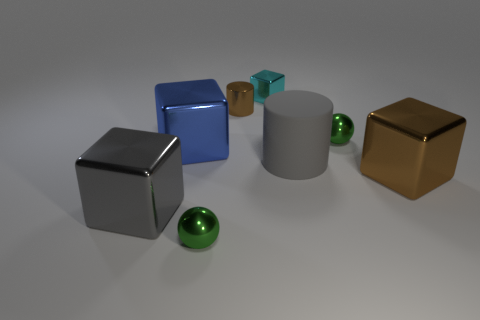Do the gray matte cylinder and the cyan object have the same size?
Make the answer very short. No. How many objects are large shiny cubes that are right of the big blue thing or metallic things in front of the big blue shiny cube?
Provide a short and direct response. 3. What number of shiny cylinders are to the left of the large metal thing right of the sphere that is in front of the gray rubber object?
Offer a very short reply. 1. There is a green ball that is on the right side of the cyan metal block; what size is it?
Offer a terse response. Small. What number of blue shiny cubes have the same size as the brown cylinder?
Offer a very short reply. 0. Does the cyan object have the same size as the green ball that is on the left side of the cyan metal object?
Your answer should be very brief. Yes. How many things are brown shiny objects or tiny cyan things?
Your answer should be very brief. 3. What number of metallic cubes are the same color as the big cylinder?
Offer a terse response. 1. There is a blue thing that is the same size as the gray metal cube; what is its shape?
Provide a short and direct response. Cube. Are there any other tiny objects of the same shape as the rubber object?
Offer a terse response. Yes. 